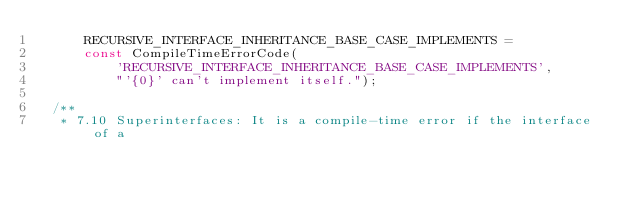<code> <loc_0><loc_0><loc_500><loc_500><_Dart_>      RECURSIVE_INTERFACE_INHERITANCE_BASE_CASE_IMPLEMENTS =
      const CompileTimeErrorCode(
          'RECURSIVE_INTERFACE_INHERITANCE_BASE_CASE_IMPLEMENTS',
          "'{0}' can't implement itself.");

  /**
   * 7.10 Superinterfaces: It is a compile-time error if the interface of a</code> 